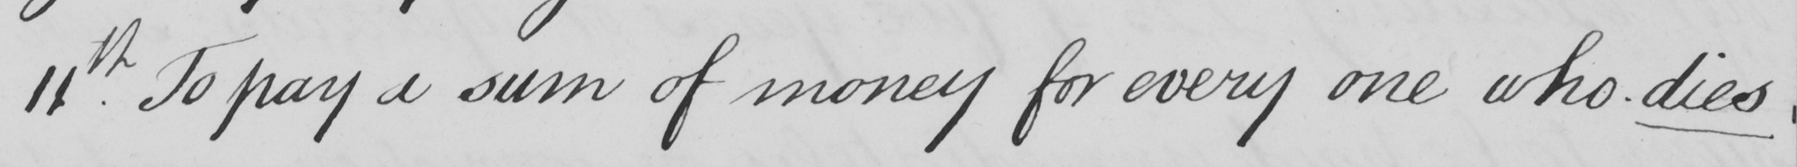Can you read and transcribe this handwriting? 11.th To pay a sum of money for every one who dies 